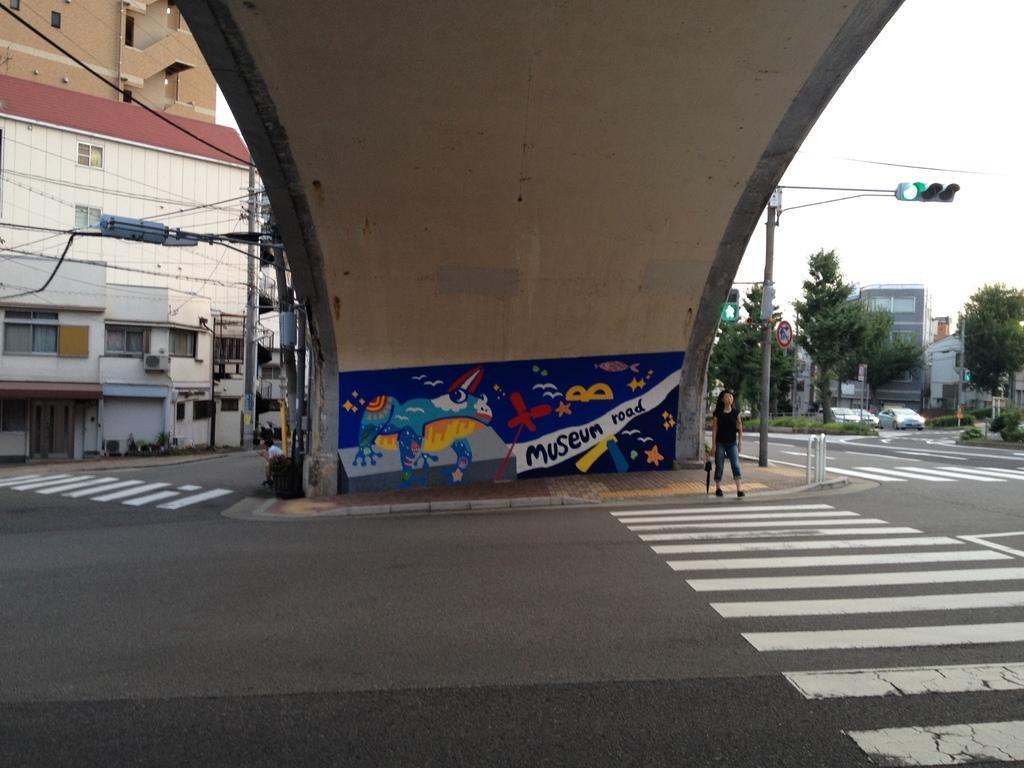In one or two sentences, can you explain what this image depicts? In this image I can see few buildings, windows, current poles, wires, traffic signals, sign boards, poles, trees, few people and few vehicles on the road. The sky is in white color. 